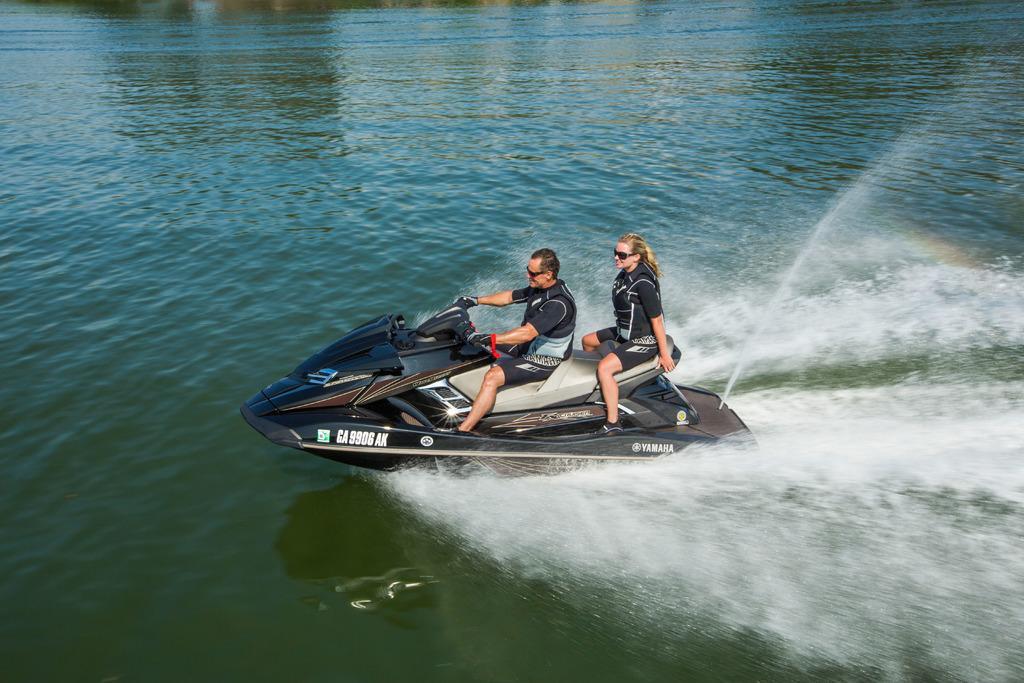Could you give a brief overview of what you see in this image? In this image I can see the water and a speed boat which is black in color on the surface of the water. I can see two persons sitting on the boat. 